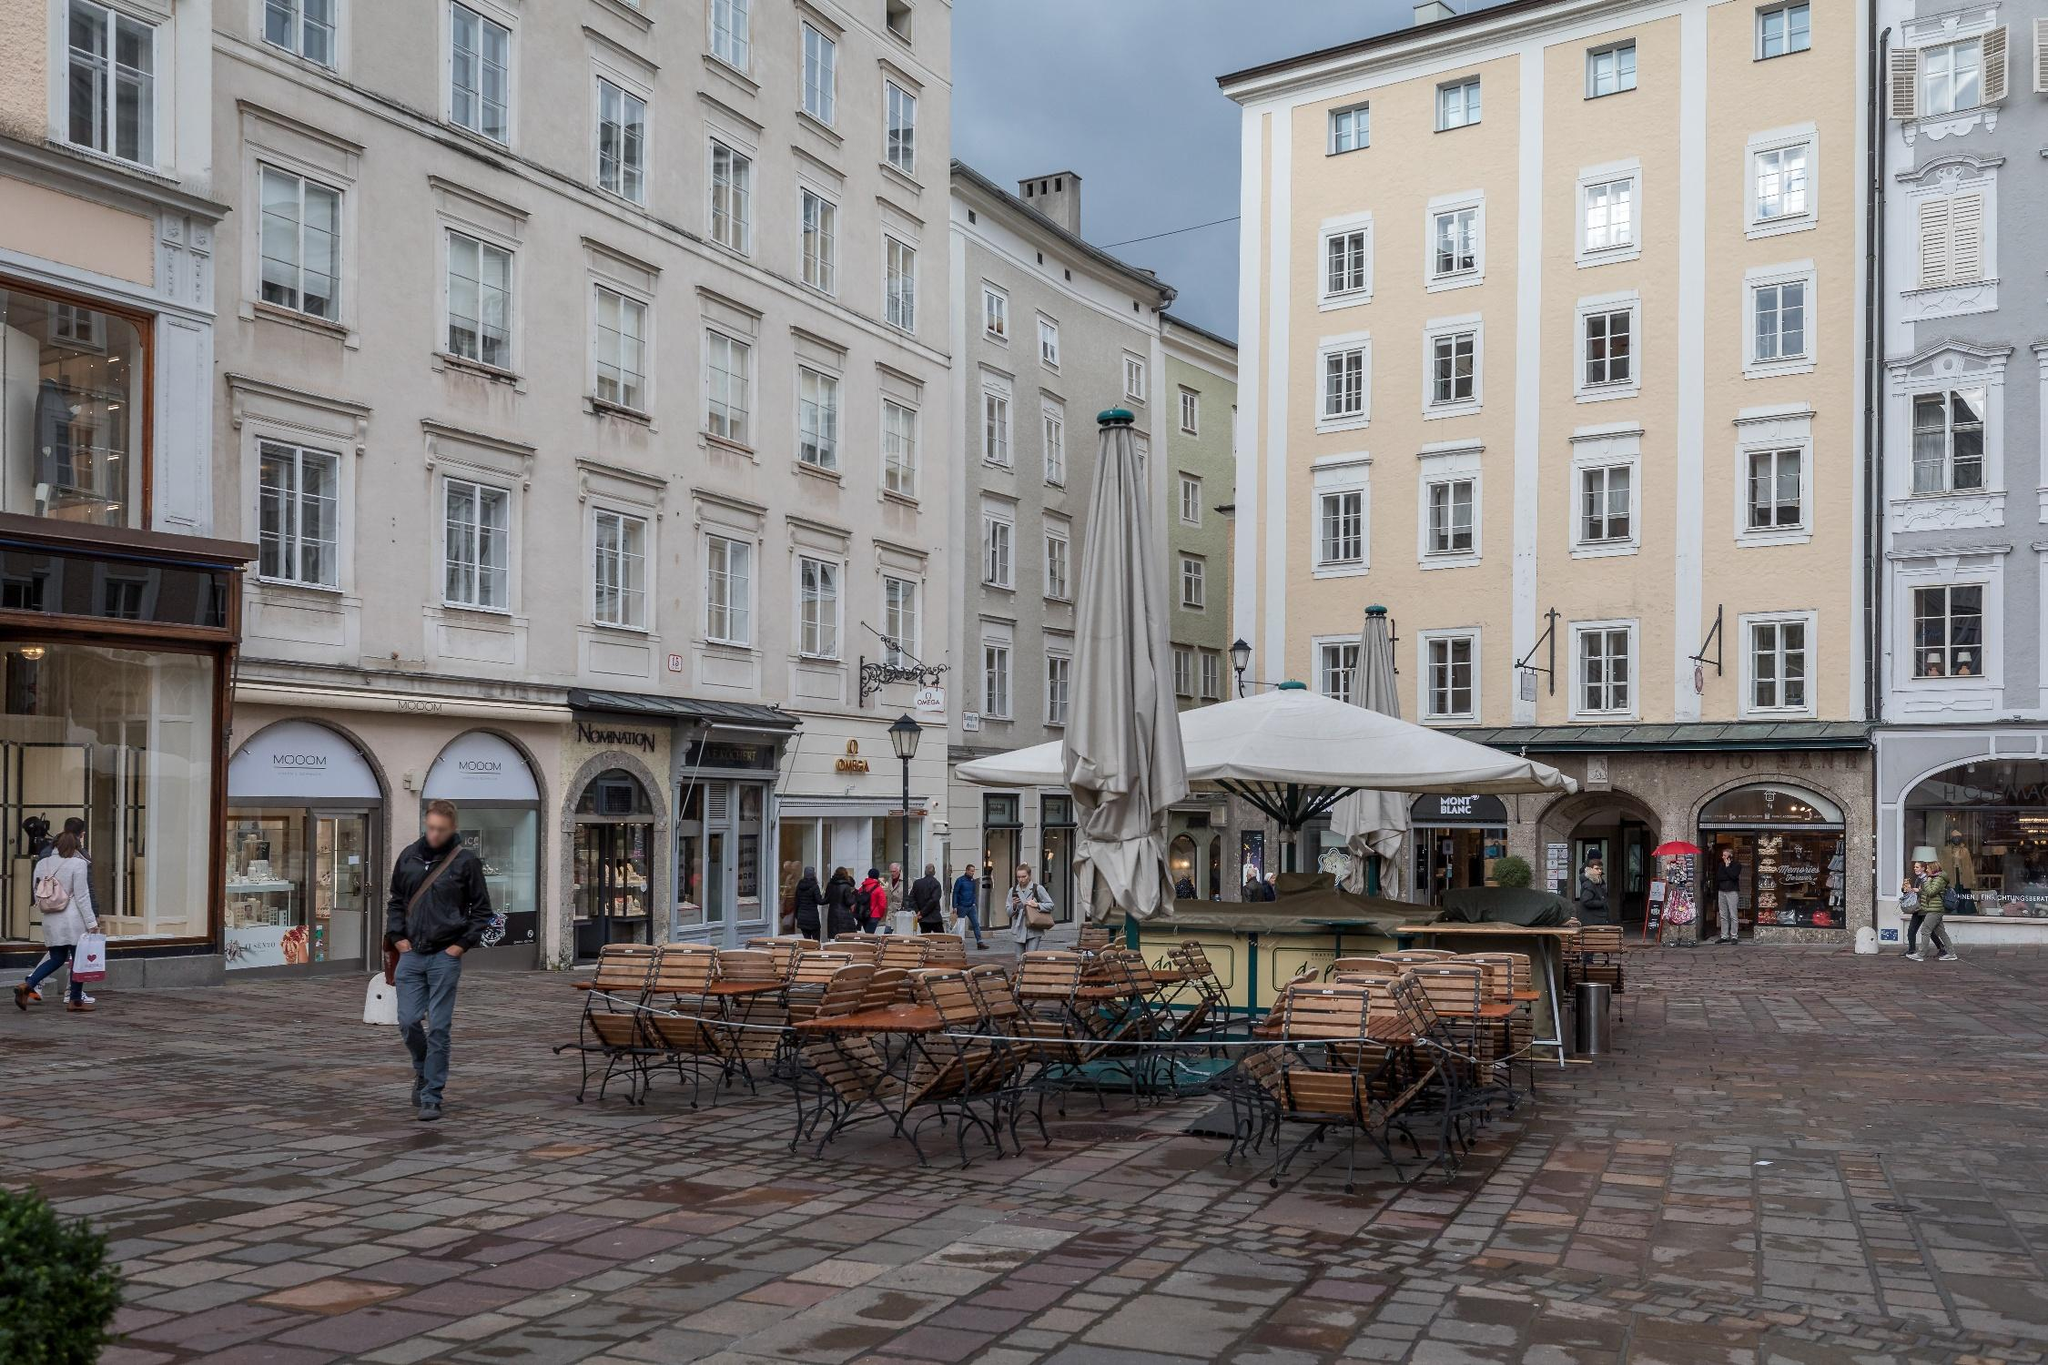Describe the atmosphere of the street corner illustrated in the image. The street corner in the image exudes a serene yet bustling ambiance. The historic architecture of the buildings, with their tall facades and uniform windows, evokes a sense of timeless European charm. The light hues of the buildings contrast beautifully with the cobblestone pavement, creating a visually appealing environment. The outdoor seating area, though unoccupied in this moment, suggests a lively spot for people to gather, indicating a social hub for both locals and visitors. The presence of pedestrians going about their day adds life to the scene, making the street corner feel vibrant and dynamic, a snapshot of everyday life in Salzburg. 